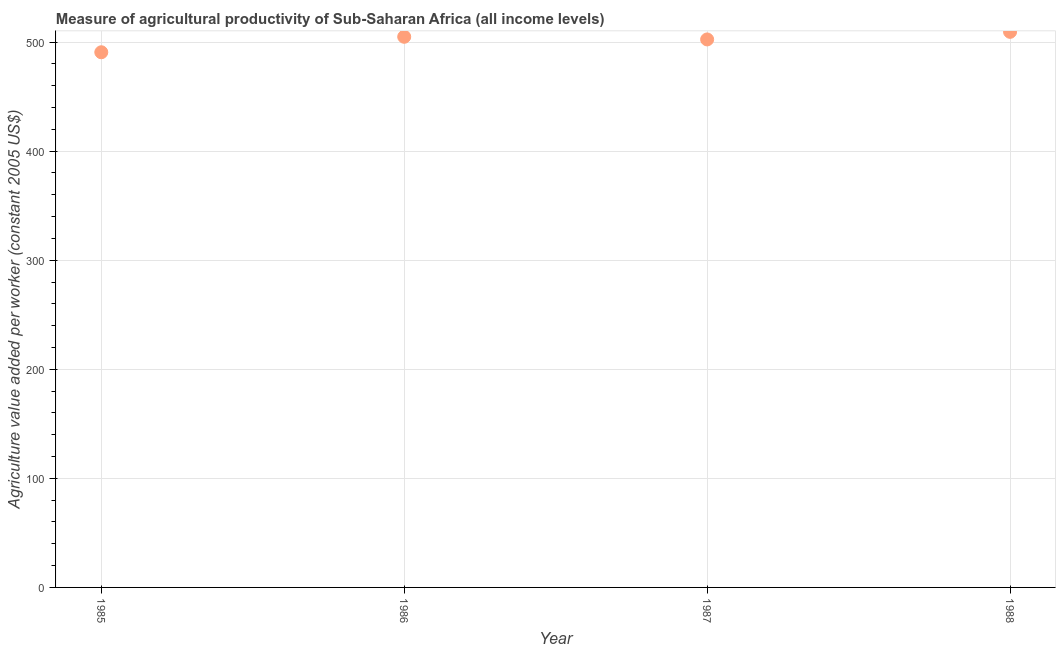What is the agriculture value added per worker in 1985?
Your answer should be compact. 490.63. Across all years, what is the maximum agriculture value added per worker?
Make the answer very short. 509.35. Across all years, what is the minimum agriculture value added per worker?
Ensure brevity in your answer.  490.63. In which year was the agriculture value added per worker minimum?
Offer a terse response. 1985. What is the sum of the agriculture value added per worker?
Offer a terse response. 2007.2. What is the difference between the agriculture value added per worker in 1987 and 1988?
Make the answer very short. -6.95. What is the average agriculture value added per worker per year?
Ensure brevity in your answer.  501.8. What is the median agriculture value added per worker?
Give a very brief answer. 503.61. What is the ratio of the agriculture value added per worker in 1985 to that in 1986?
Your answer should be compact. 0.97. Is the agriculture value added per worker in 1985 less than that in 1988?
Offer a terse response. Yes. Is the difference between the agriculture value added per worker in 1985 and 1988 greater than the difference between any two years?
Your answer should be compact. Yes. What is the difference between the highest and the second highest agriculture value added per worker?
Offer a very short reply. 4.53. What is the difference between the highest and the lowest agriculture value added per worker?
Provide a succinct answer. 18.72. In how many years, is the agriculture value added per worker greater than the average agriculture value added per worker taken over all years?
Make the answer very short. 3. Does the agriculture value added per worker monotonically increase over the years?
Give a very brief answer. No. How many dotlines are there?
Provide a succinct answer. 1. How many years are there in the graph?
Give a very brief answer. 4. What is the difference between two consecutive major ticks on the Y-axis?
Keep it short and to the point. 100. Are the values on the major ticks of Y-axis written in scientific E-notation?
Ensure brevity in your answer.  No. Does the graph contain any zero values?
Keep it short and to the point. No. What is the title of the graph?
Ensure brevity in your answer.  Measure of agricultural productivity of Sub-Saharan Africa (all income levels). What is the label or title of the Y-axis?
Offer a very short reply. Agriculture value added per worker (constant 2005 US$). What is the Agriculture value added per worker (constant 2005 US$) in 1985?
Your answer should be compact. 490.63. What is the Agriculture value added per worker (constant 2005 US$) in 1986?
Ensure brevity in your answer.  504.82. What is the Agriculture value added per worker (constant 2005 US$) in 1987?
Give a very brief answer. 502.4. What is the Agriculture value added per worker (constant 2005 US$) in 1988?
Keep it short and to the point. 509.35. What is the difference between the Agriculture value added per worker (constant 2005 US$) in 1985 and 1986?
Ensure brevity in your answer.  -14.19. What is the difference between the Agriculture value added per worker (constant 2005 US$) in 1985 and 1987?
Provide a short and direct response. -11.77. What is the difference between the Agriculture value added per worker (constant 2005 US$) in 1985 and 1988?
Your answer should be compact. -18.72. What is the difference between the Agriculture value added per worker (constant 2005 US$) in 1986 and 1987?
Your answer should be compact. 2.42. What is the difference between the Agriculture value added per worker (constant 2005 US$) in 1986 and 1988?
Your answer should be compact. -4.53. What is the difference between the Agriculture value added per worker (constant 2005 US$) in 1987 and 1988?
Your answer should be very brief. -6.95. What is the ratio of the Agriculture value added per worker (constant 2005 US$) in 1985 to that in 1986?
Provide a succinct answer. 0.97. What is the ratio of the Agriculture value added per worker (constant 2005 US$) in 1987 to that in 1988?
Offer a terse response. 0.99. 